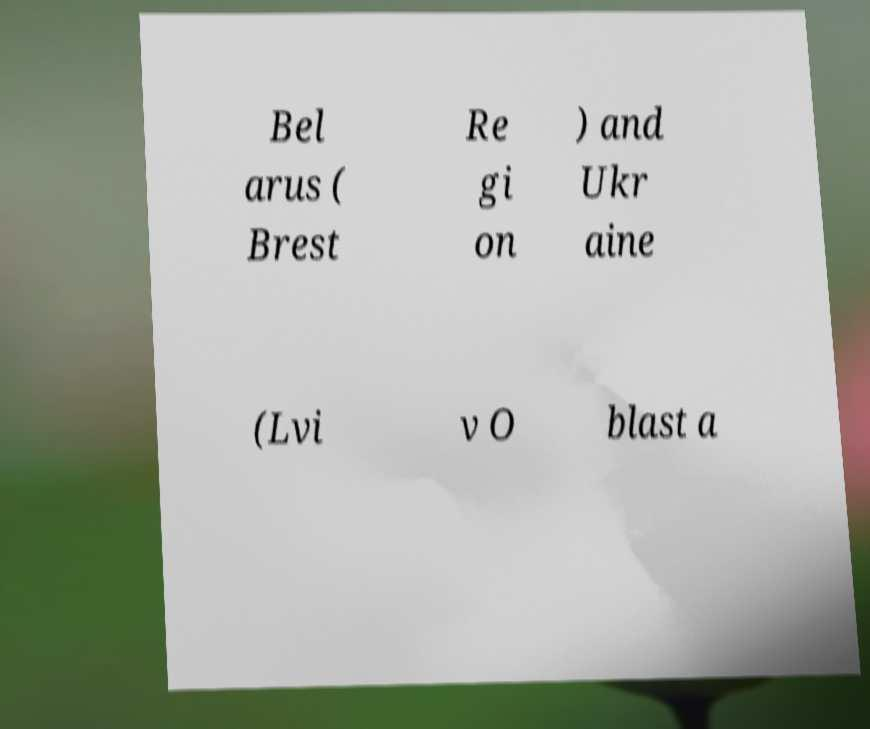For documentation purposes, I need the text within this image transcribed. Could you provide that? Bel arus ( Brest Re gi on ) and Ukr aine (Lvi v O blast a 